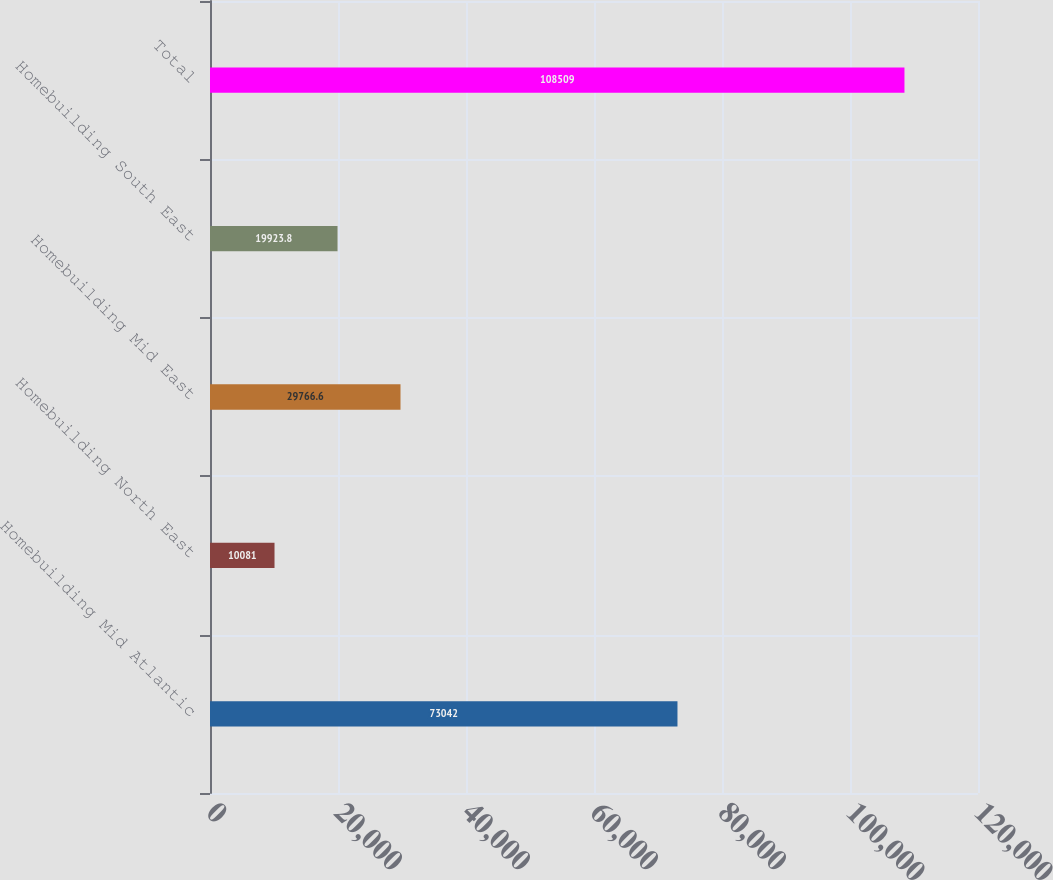<chart> <loc_0><loc_0><loc_500><loc_500><bar_chart><fcel>Homebuilding Mid Atlantic<fcel>Homebuilding North East<fcel>Homebuilding Mid East<fcel>Homebuilding South East<fcel>Total<nl><fcel>73042<fcel>10081<fcel>29766.6<fcel>19923.8<fcel>108509<nl></chart> 